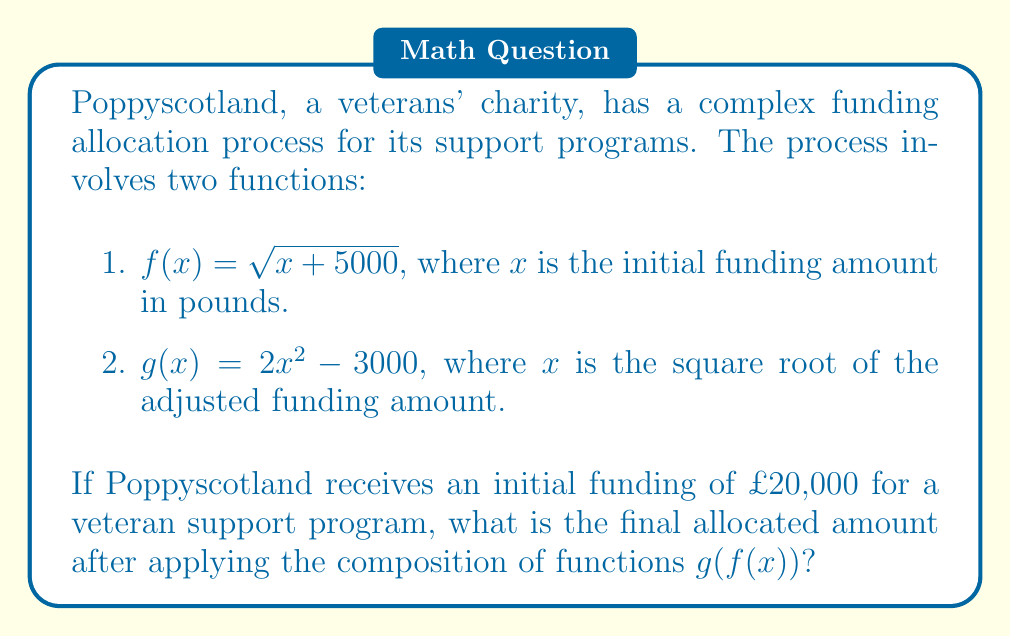Can you solve this math problem? To solve this problem, we need to apply the composition of functions $g(f(x))$. This means we first apply function $f$, and then apply function $g$ to the result.

Step 1: Apply $f(x)$ to the initial funding amount.
$f(20000) = \sqrt{20000 + 5000} = \sqrt{25000} = 158.11$ (rounded to 2 decimal places)

Step 2: Now, we use this result as the input for function $g(x)$.
$g(158.11) = 2(158.11)^2 - 3000$

Step 3: Calculate the final result.
$g(158.11) = 2(25000.98) - 3000 = 50001.96 - 3000 = 47001.96$

Therefore, the final allocated amount after applying the composition of functions $g(f(x))$ is £47,001.96.
Answer: £47,001.96 